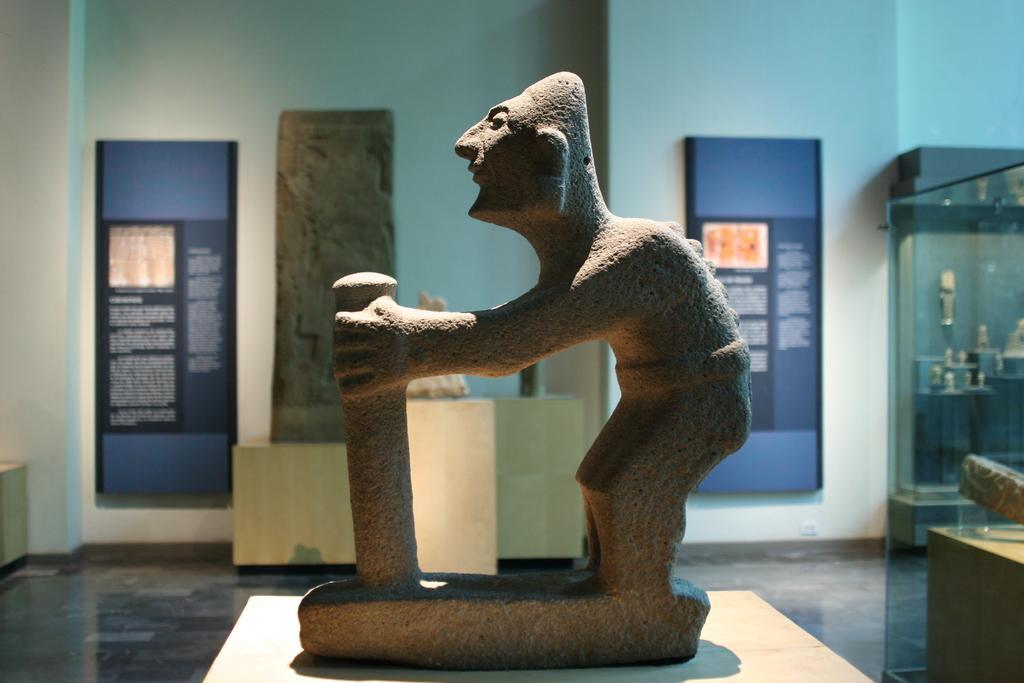How would you summarize this image in a sentence or two? In this picture we can see there are sculptures, boards and the wall. On the right side of the image, there is a transparent glass and some other objects. 